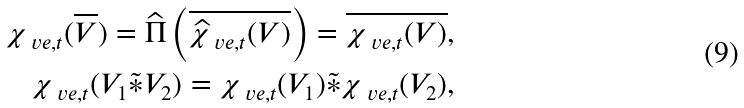Convert formula to latex. <formula><loc_0><loc_0><loc_500><loc_500>\chi _ { \ v e , t } ( \overline { V } ) = \widehat { \Pi } \left ( \overline { \widehat { \chi } _ { \ v e , t } ( V ) } \right ) = \overline { \chi _ { \ v e , t } ( V ) } , \\ \chi _ { \ v e , t } ( V _ { 1 } \tilde { \ast } V _ { 2 } ) = \chi _ { \ v e , t } ( V _ { 1 } ) \tilde { \ast } \chi _ { \ v e , t } ( V _ { 2 } ) ,</formula> 